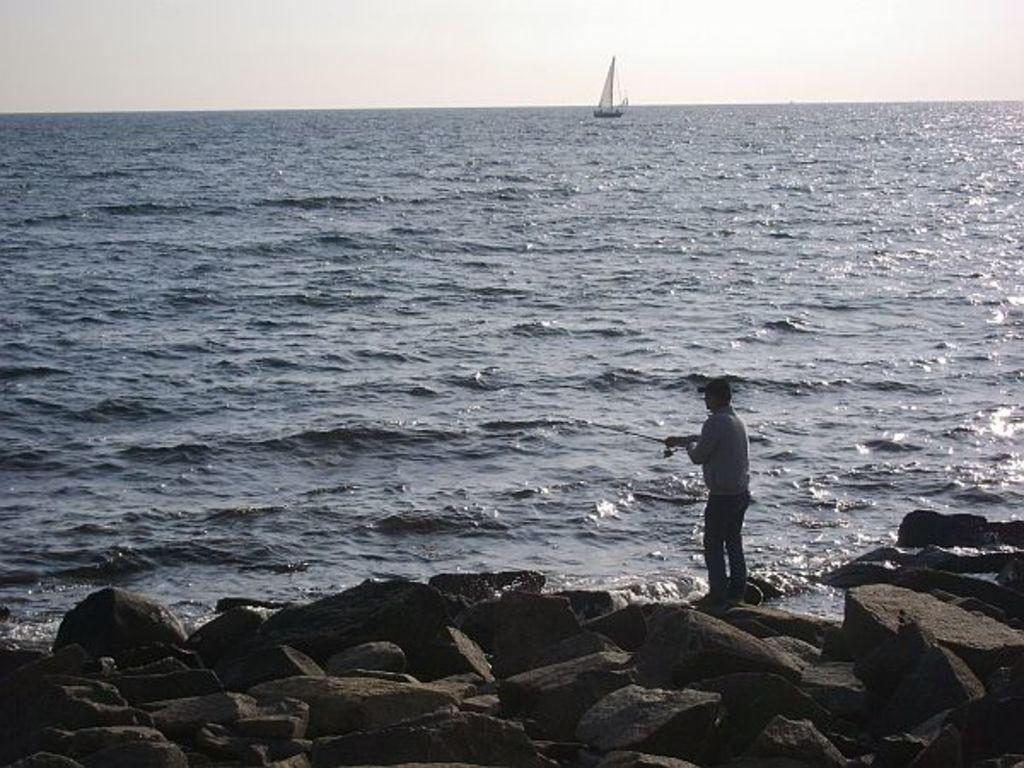What is the main subject of the image? There is a ship in the image. Where is the ship located? The ship is on the water. What can be seen in the front of the image? There are rocks in the front of the image. What is the person in the image doing? The person is standing and holding a stick. What type of stew is being cooked on the ship's engine in the image? There is no stew or engine present in the image; it features a ship on the water with a person holding a stick. What material is the leather used for the ship's sails in the image? There is no leather or sails mentioned in the image; it only shows a ship on the water, rocks, and a person holding a stick. 